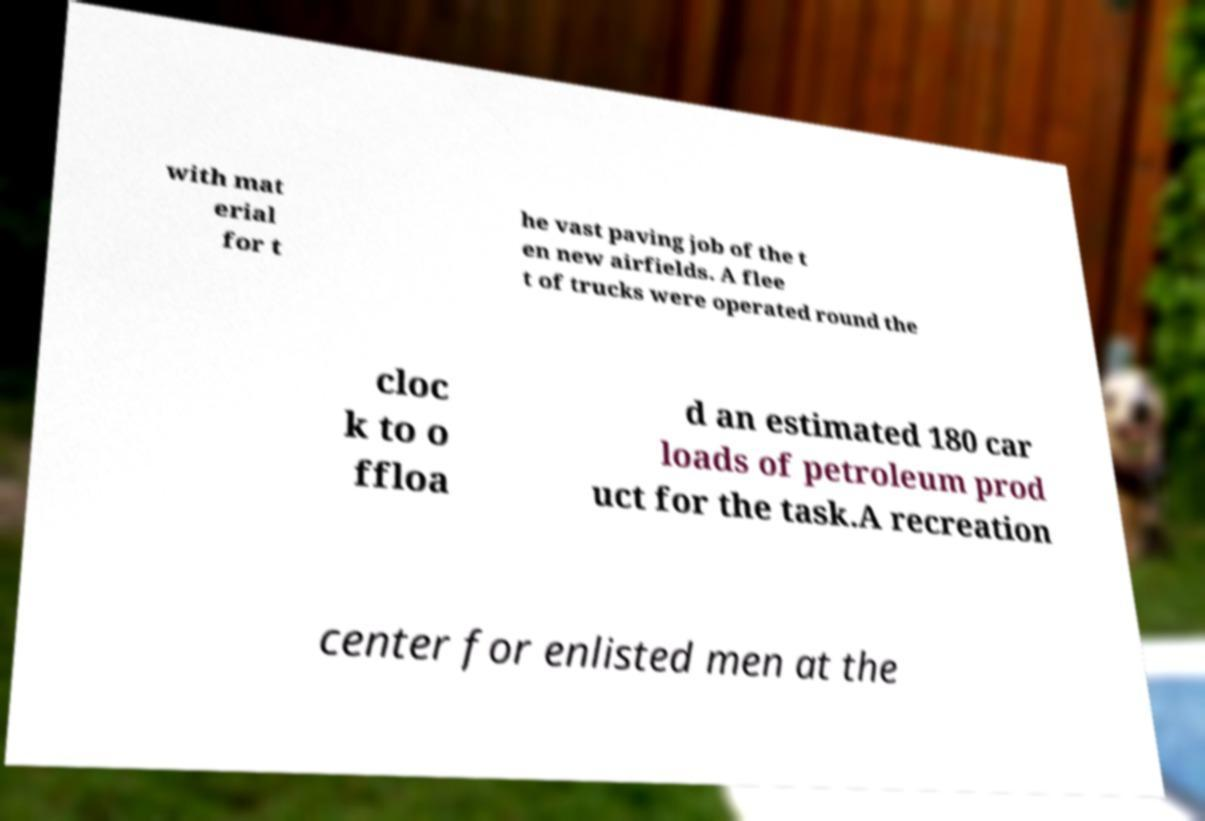Could you extract and type out the text from this image? with mat erial for t he vast paving job of the t en new airfields. A flee t of trucks were operated round the cloc k to o ffloa d an estimated 180 car loads of petroleum prod uct for the task.A recreation center for enlisted men at the 